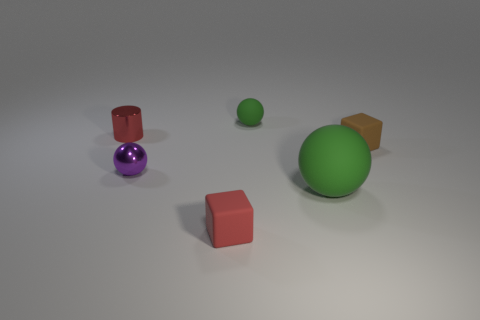What hues are present in this assortment of items, and how would you describe their textures? The objects in the image have a variety of hues: there are two balls, one green and one purple, both with a smooth and slightly shiny texture suggesting they might be made of plastic. The red and orange cubes also have a matte finish. The colors are all solid and vibrant, giving the scene a playful and simple aesthetic. 